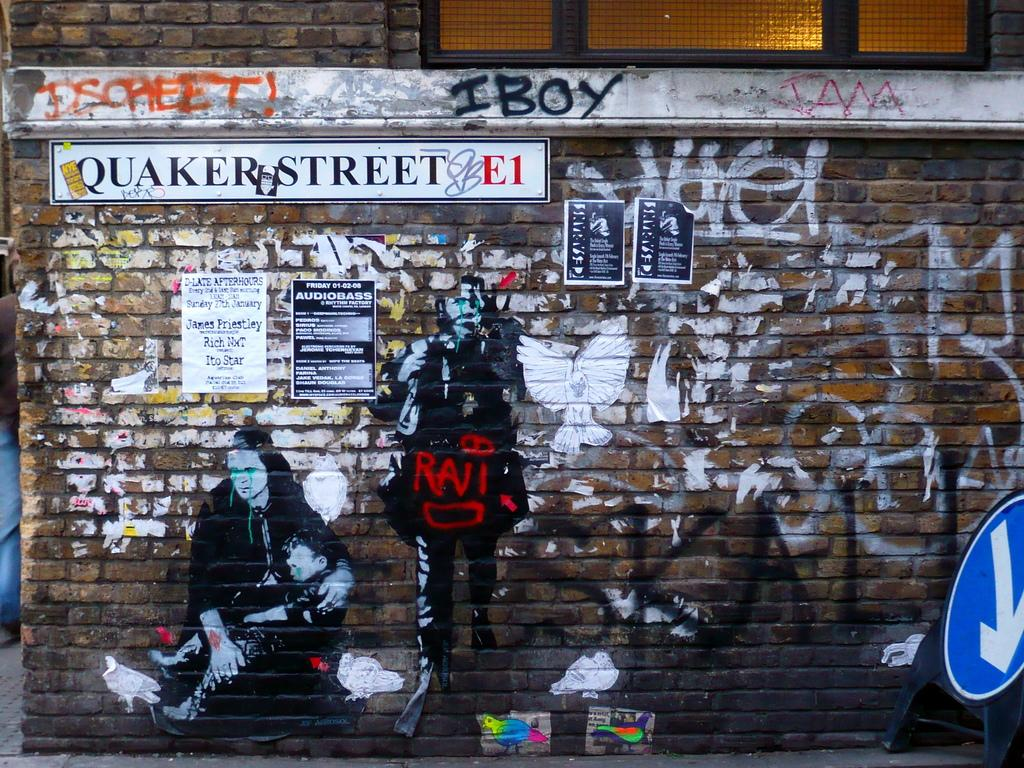What is attached to the wall in the image? There are posts attached to the wall in the image. What is displayed on the wall in the image? There are paintings on the wall in the image. What type of flat, rigid material can be seen in the image? There are boards in the image. Can you describe any other objects present in the image? There are other objects present in the image, but their specific details are not mentioned in the provided facts. How many eggs are visible in the image? There are no eggs present in the image. What type of pain is the person in the image experiencing? There is no person present in the image, so it is not possible to determine if they are experiencing any pain. --- Facts: 1. There is a person sitting on a chair in the image. 2. The person is holding a book. 3. The book has a blue cover. 4. The chair is made of wood. 5. There is a table next to the chair. Absurd Topics: fish, ocean, waves Conversation: What is the person in the image doing? The person is sitting on a chair in the image. What is the person holding in the image? The person is holding a book in the image. What color is the book's cover? The book has a blue cover. What material is the chair made of? The chair is made of wood. What is located next to the chair in the image? There is a table next to the chair in the image. Reasoning: Let's think step by step in order to produce the conversation. We start by identifying the main subject in the image, which is the person sitting on a chair. Then, we expand the conversation to include other items that are also visible, such as the book, the book's cover color, the chair's material, and the table. Each question is designed to elicit a specific detail about the image that is known from the provided facts. Absurd Question/Answer: Can you see any fish swimming in the ocean in the image? There is no ocean or fish present in the image. What type of waves can be seen in the image? There are no waves present in the image. 